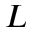Convert formula to latex. <formula><loc_0><loc_0><loc_500><loc_500>L</formula> 